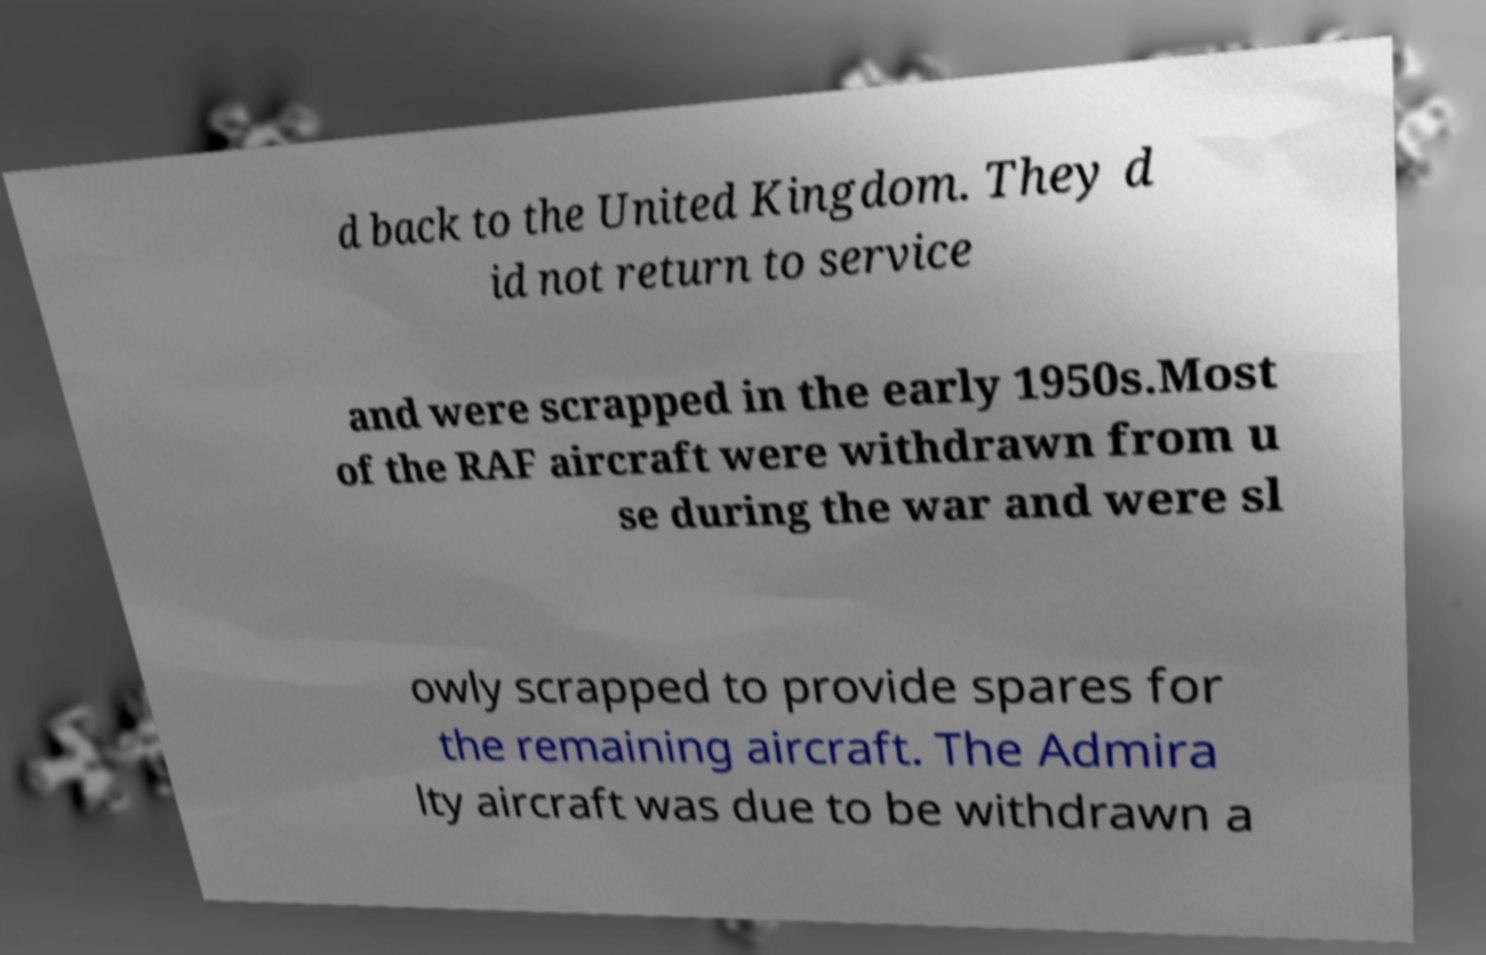Can you read and provide the text displayed in the image?This photo seems to have some interesting text. Can you extract and type it out for me? d back to the United Kingdom. They d id not return to service and were scrapped in the early 1950s.Most of the RAF aircraft were withdrawn from u se during the war and were sl owly scrapped to provide spares for the remaining aircraft. The Admira lty aircraft was due to be withdrawn a 